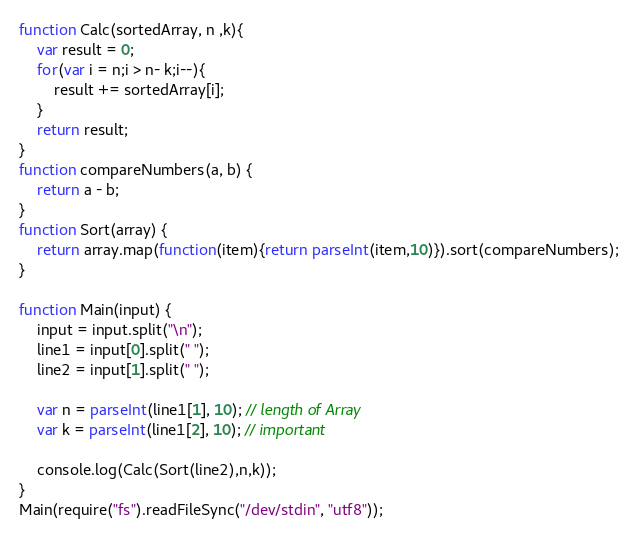Convert code to text. <code><loc_0><loc_0><loc_500><loc_500><_JavaScript_>function Calc(sortedArray, n ,k){
    var result = 0;
    for(var i = n;i > n- k;i--){
        result += sortedArray[i];
    }
    return result;
}
function compareNumbers(a, b) {
    return a - b;
}
function Sort(array) {
    return array.map(function(item){return parseInt(item,10)}).sort(compareNumbers);
}

function Main(input) {
    input = input.split("\n");
    line1 = input[0].split(" ");
    line2 = input[1].split(" ");

    var n = parseInt(line1[1], 10); // length of Array
    var k = parseInt(line1[2], 10); // important

    console.log(Calc(Sort(line2),n,k));
}
Main(require("fs").readFileSync("/dev/stdin", "utf8"));
</code> 